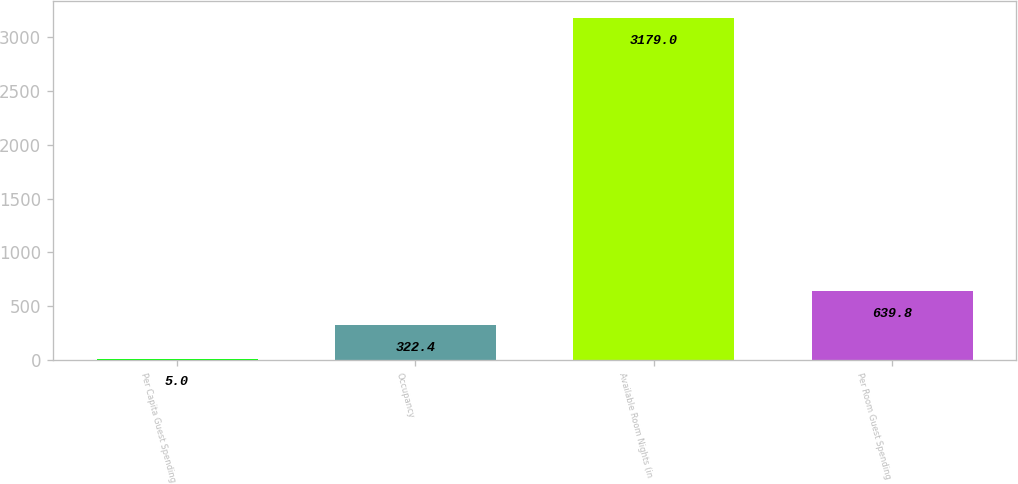<chart> <loc_0><loc_0><loc_500><loc_500><bar_chart><fcel>Per Capita Guest Spending<fcel>Occupancy<fcel>Available Room Nights (in<fcel>Per Room Guest Spending<nl><fcel>5<fcel>322.4<fcel>3179<fcel>639.8<nl></chart> 